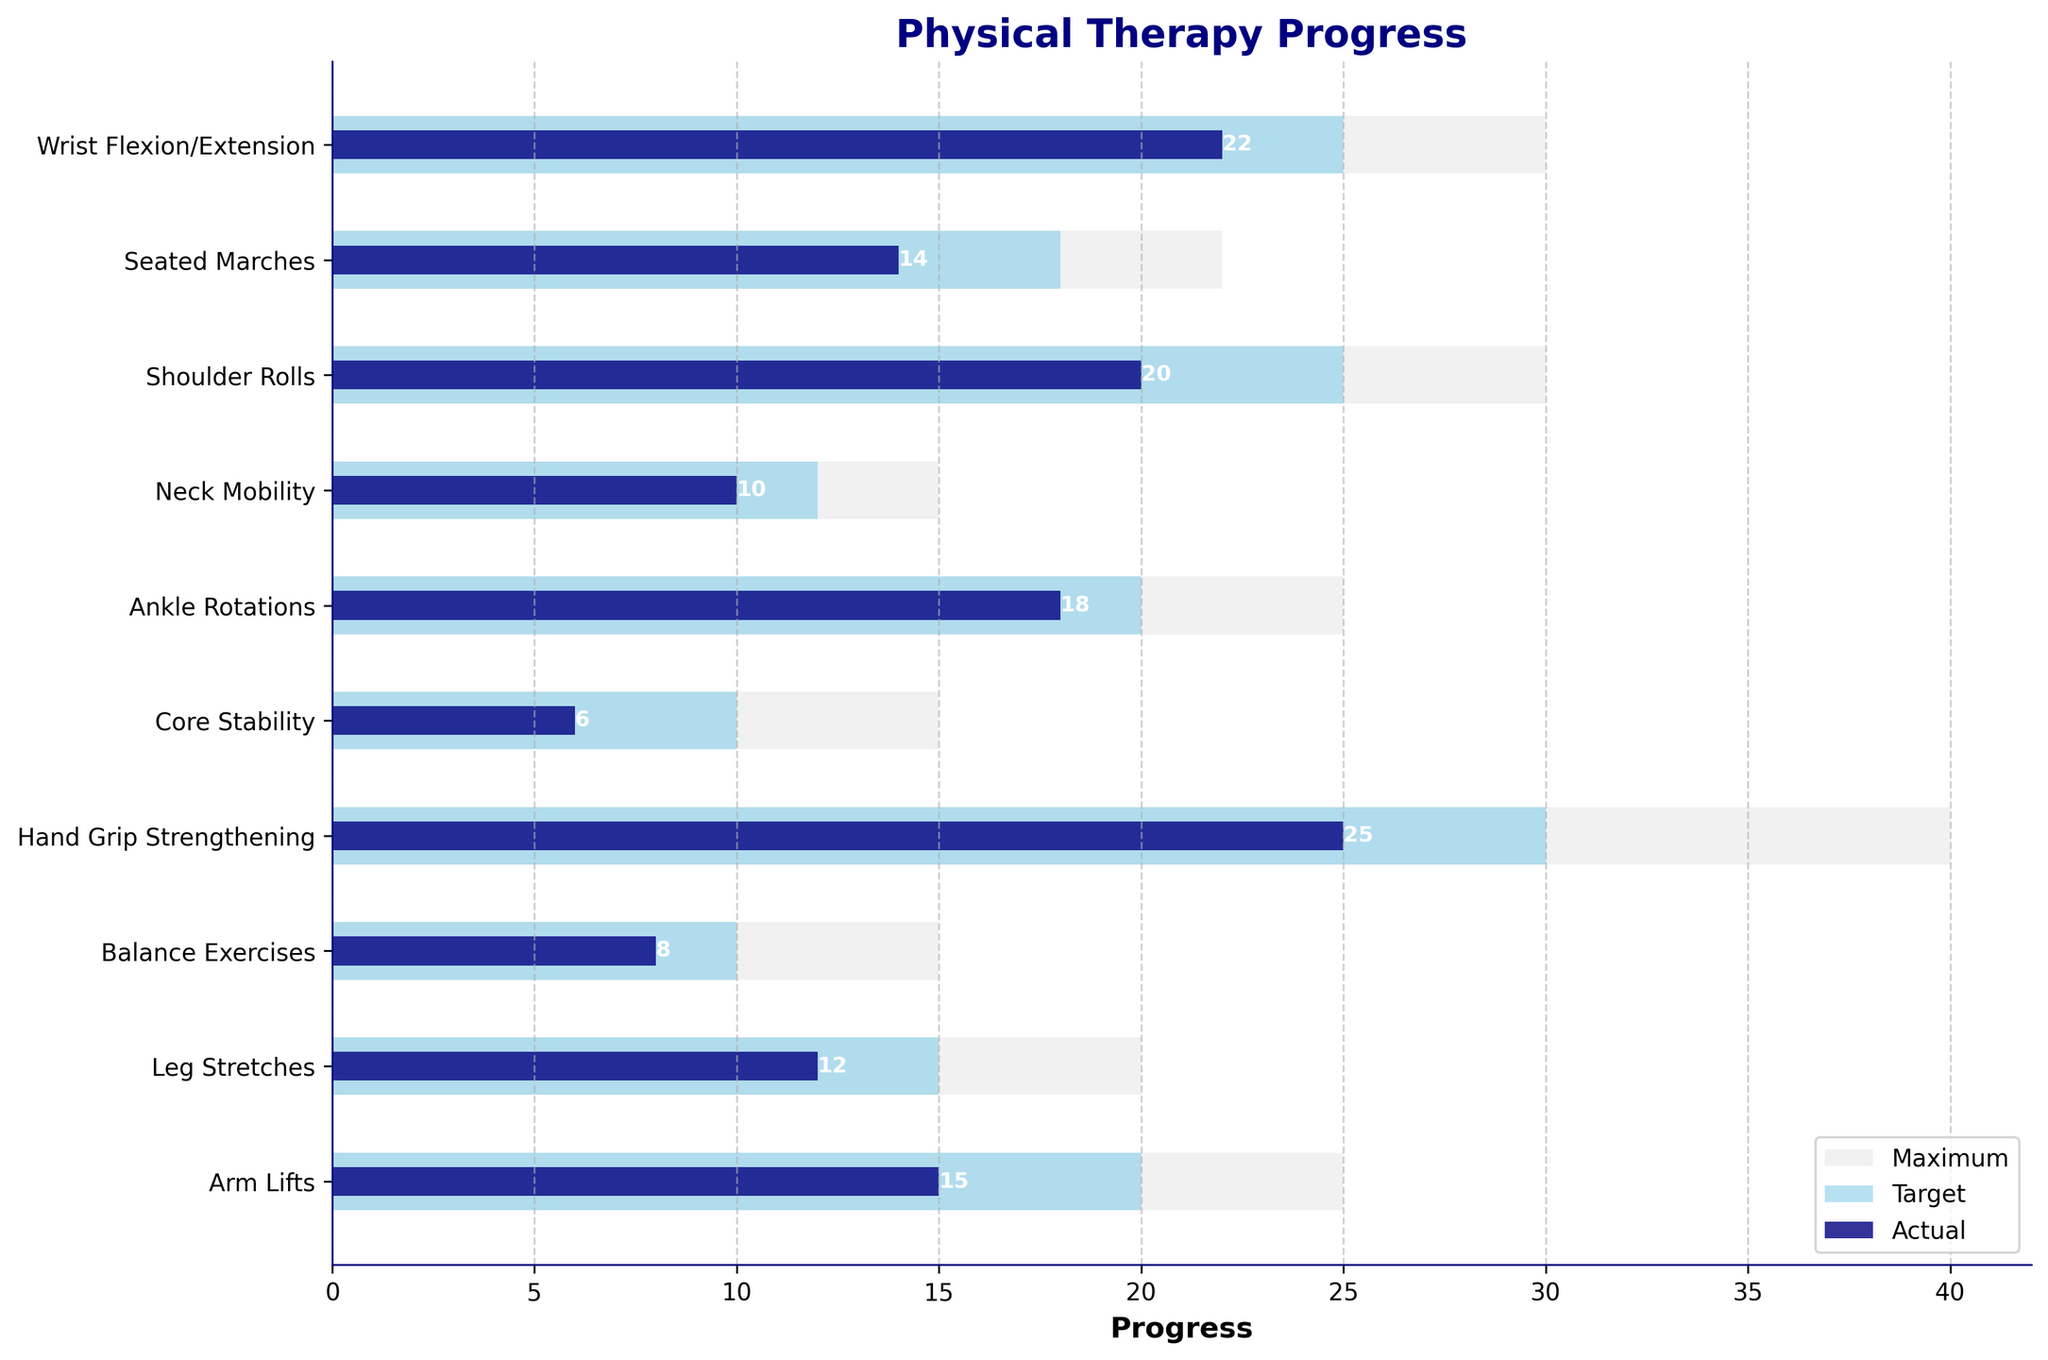What is the title of the chart? The title of the chart is displayed above the figure, indicating what the chart represents.
Answer: Physical Therapy Progress How many types of exercises are shown in the chart? The chart's y-axis lists all the types of exercises. Counting these labels gives the total number.
Answer: 10 Which exercise has the highest actual progress? Compare the 'Actual' progress bars for each exercise. The longest bar represents the highest actual progress.
Answer: Hand Grip Strengthening What is the target progress for the 'Core Stability' exercise? Identify the 'Core Stability' exercise on the y-axis and follow its corresponding 'Target' progress bar.
Answer: 10 How does the 'Ankle Rotations' actual progress compare to its target? Compare the length of the 'Actual' and 'Target' bars for 'Ankle Rotations'.
Answer: It is 2 units less What is the difference between the actual and maximum progress for 'Neck Mobility'? Subtract the 'Actual' progress value from the 'Max' progress value for 'Neck Mobility'.
Answer: 5 Which exercises have an actual progress that exceeds their target? Identify exercises where the 'Actual' progress bar is longer than the 'Target' progress bar.
Answer: Seated Marches, Wrist Flexion/Extension What is the range of the target progress values? Identify the minimum and maximum values among the 'Target' progress values, and subtract the minimum from the maximum.
Answer: 8 (30-22) Which exercise is closest to meeting its maximum progress? Compare the 'Actual' and 'Max' progress bars for each exercise and find the one with the smallest difference.
Answer: Ankle Rotations Which exercise has the smallest difference between actual and target progress? Subtract the 'Actual' values from the 'Target' values for each exercise and find the smallest difference.
Answer: Seated Marches 